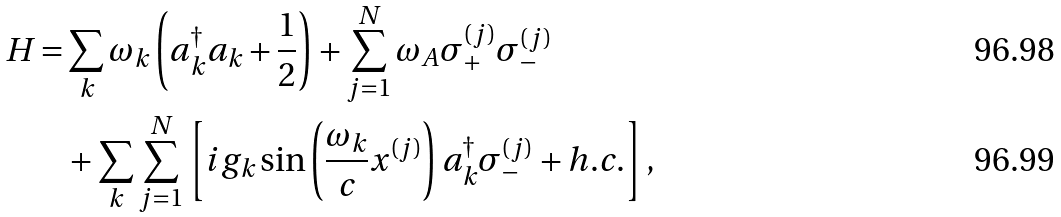<formula> <loc_0><loc_0><loc_500><loc_500>H = & \sum _ { k } \omega _ { k } \left ( a _ { k } ^ { \dag } a _ { k } + \frac { 1 } { 2 } \right ) + \sum _ { j = 1 } ^ { N } \omega _ { A } \sigma _ { + } ^ { ( j ) } \sigma _ { - } ^ { ( j ) } \\ & + \sum _ { k } \sum _ { j = 1 } ^ { N } \left [ i g _ { k } \sin \left ( \frac { \omega _ { k } } { c } x ^ { ( j ) } \right ) a _ { k } ^ { \dagger } \sigma _ { - } ^ { ( j ) } + h . c . \right ] ,</formula> 